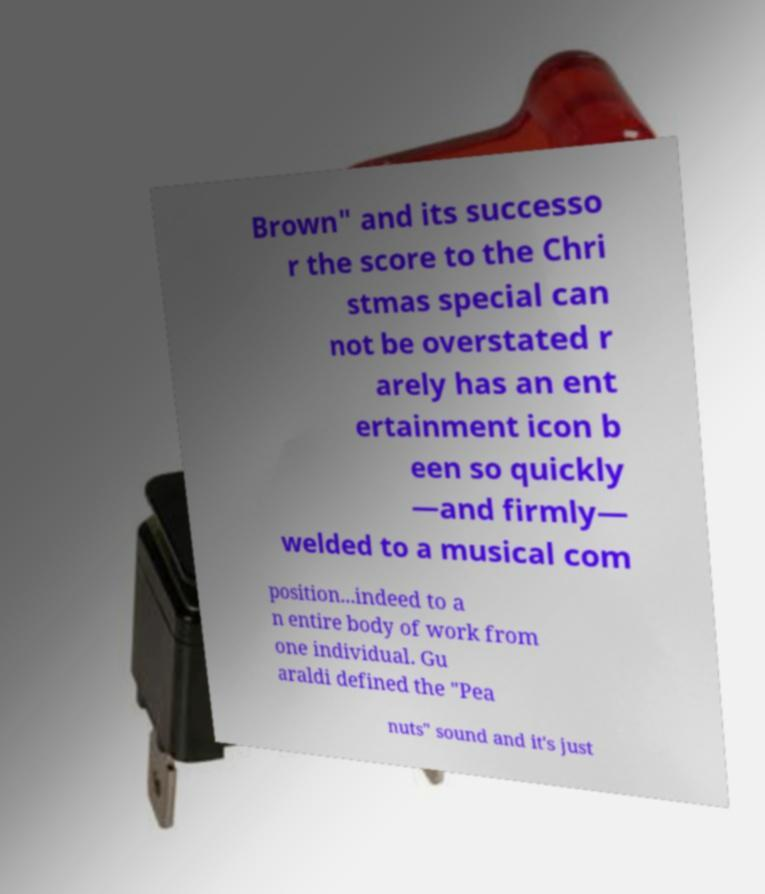There's text embedded in this image that I need extracted. Can you transcribe it verbatim? Brown" and its successo r the score to the Chri stmas special can not be overstated r arely has an ent ertainment icon b een so quickly —and firmly— welded to a musical com position...indeed to a n entire body of work from one individual. Gu araldi defined the "Pea nuts" sound and it's just 